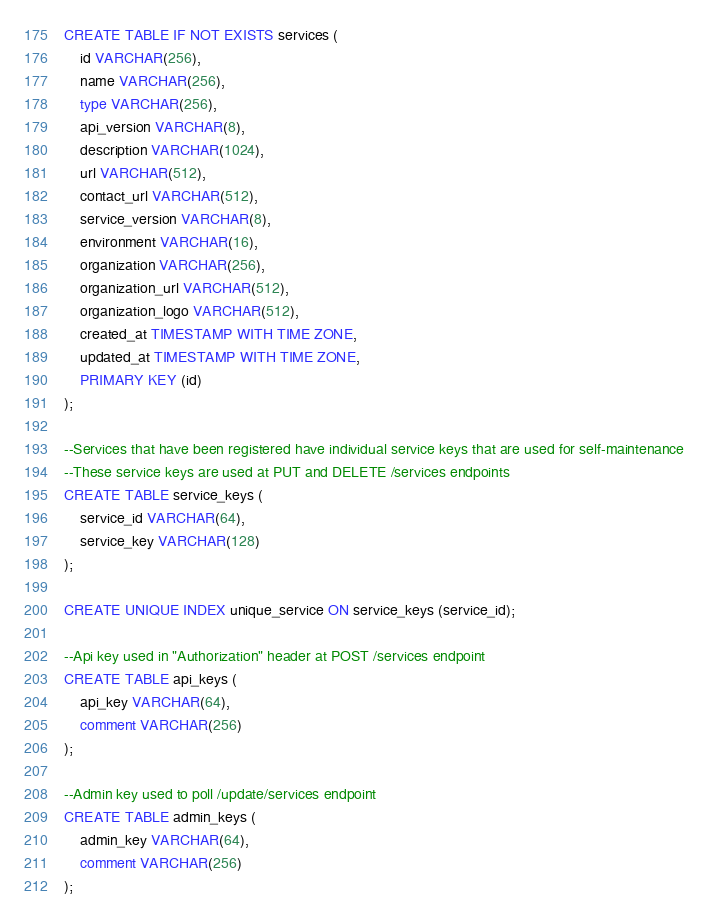<code> <loc_0><loc_0><loc_500><loc_500><_SQL_>CREATE TABLE IF NOT EXISTS services (
    id VARCHAR(256),
    name VARCHAR(256),
    type VARCHAR(256),
    api_version VARCHAR(8),
    description VARCHAR(1024),
    url VARCHAR(512),
    contact_url VARCHAR(512),
    service_version VARCHAR(8),
    environment VARCHAR(16),
    organization VARCHAR(256),
    organization_url VARCHAR(512),
    organization_logo VARCHAR(512),
    created_at TIMESTAMP WITH TIME ZONE,
    updated_at TIMESTAMP WITH TIME ZONE,
    PRIMARY KEY (id)
);

--Services that have been registered have individual service keys that are used for self-maintenance
--These service keys are used at PUT and DELETE /services endpoints
CREATE TABLE service_keys (
    service_id VARCHAR(64),
    service_key VARCHAR(128)
);

CREATE UNIQUE INDEX unique_service ON service_keys (service_id);

--Api key used in "Authorization" header at POST /services endpoint
CREATE TABLE api_keys (
    api_key VARCHAR(64),
    comment VARCHAR(256)
);

--Admin key used to poll /update/services endpoint
CREATE TABLE admin_keys (
    admin_key VARCHAR(64),
    comment VARCHAR(256)
);
</code> 